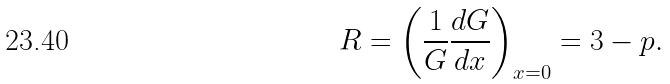Convert formula to latex. <formula><loc_0><loc_0><loc_500><loc_500>R = \left ( \frac { 1 } { G } \frac { d G } { d x } \right ) _ { x = 0 } = 3 - p .</formula> 